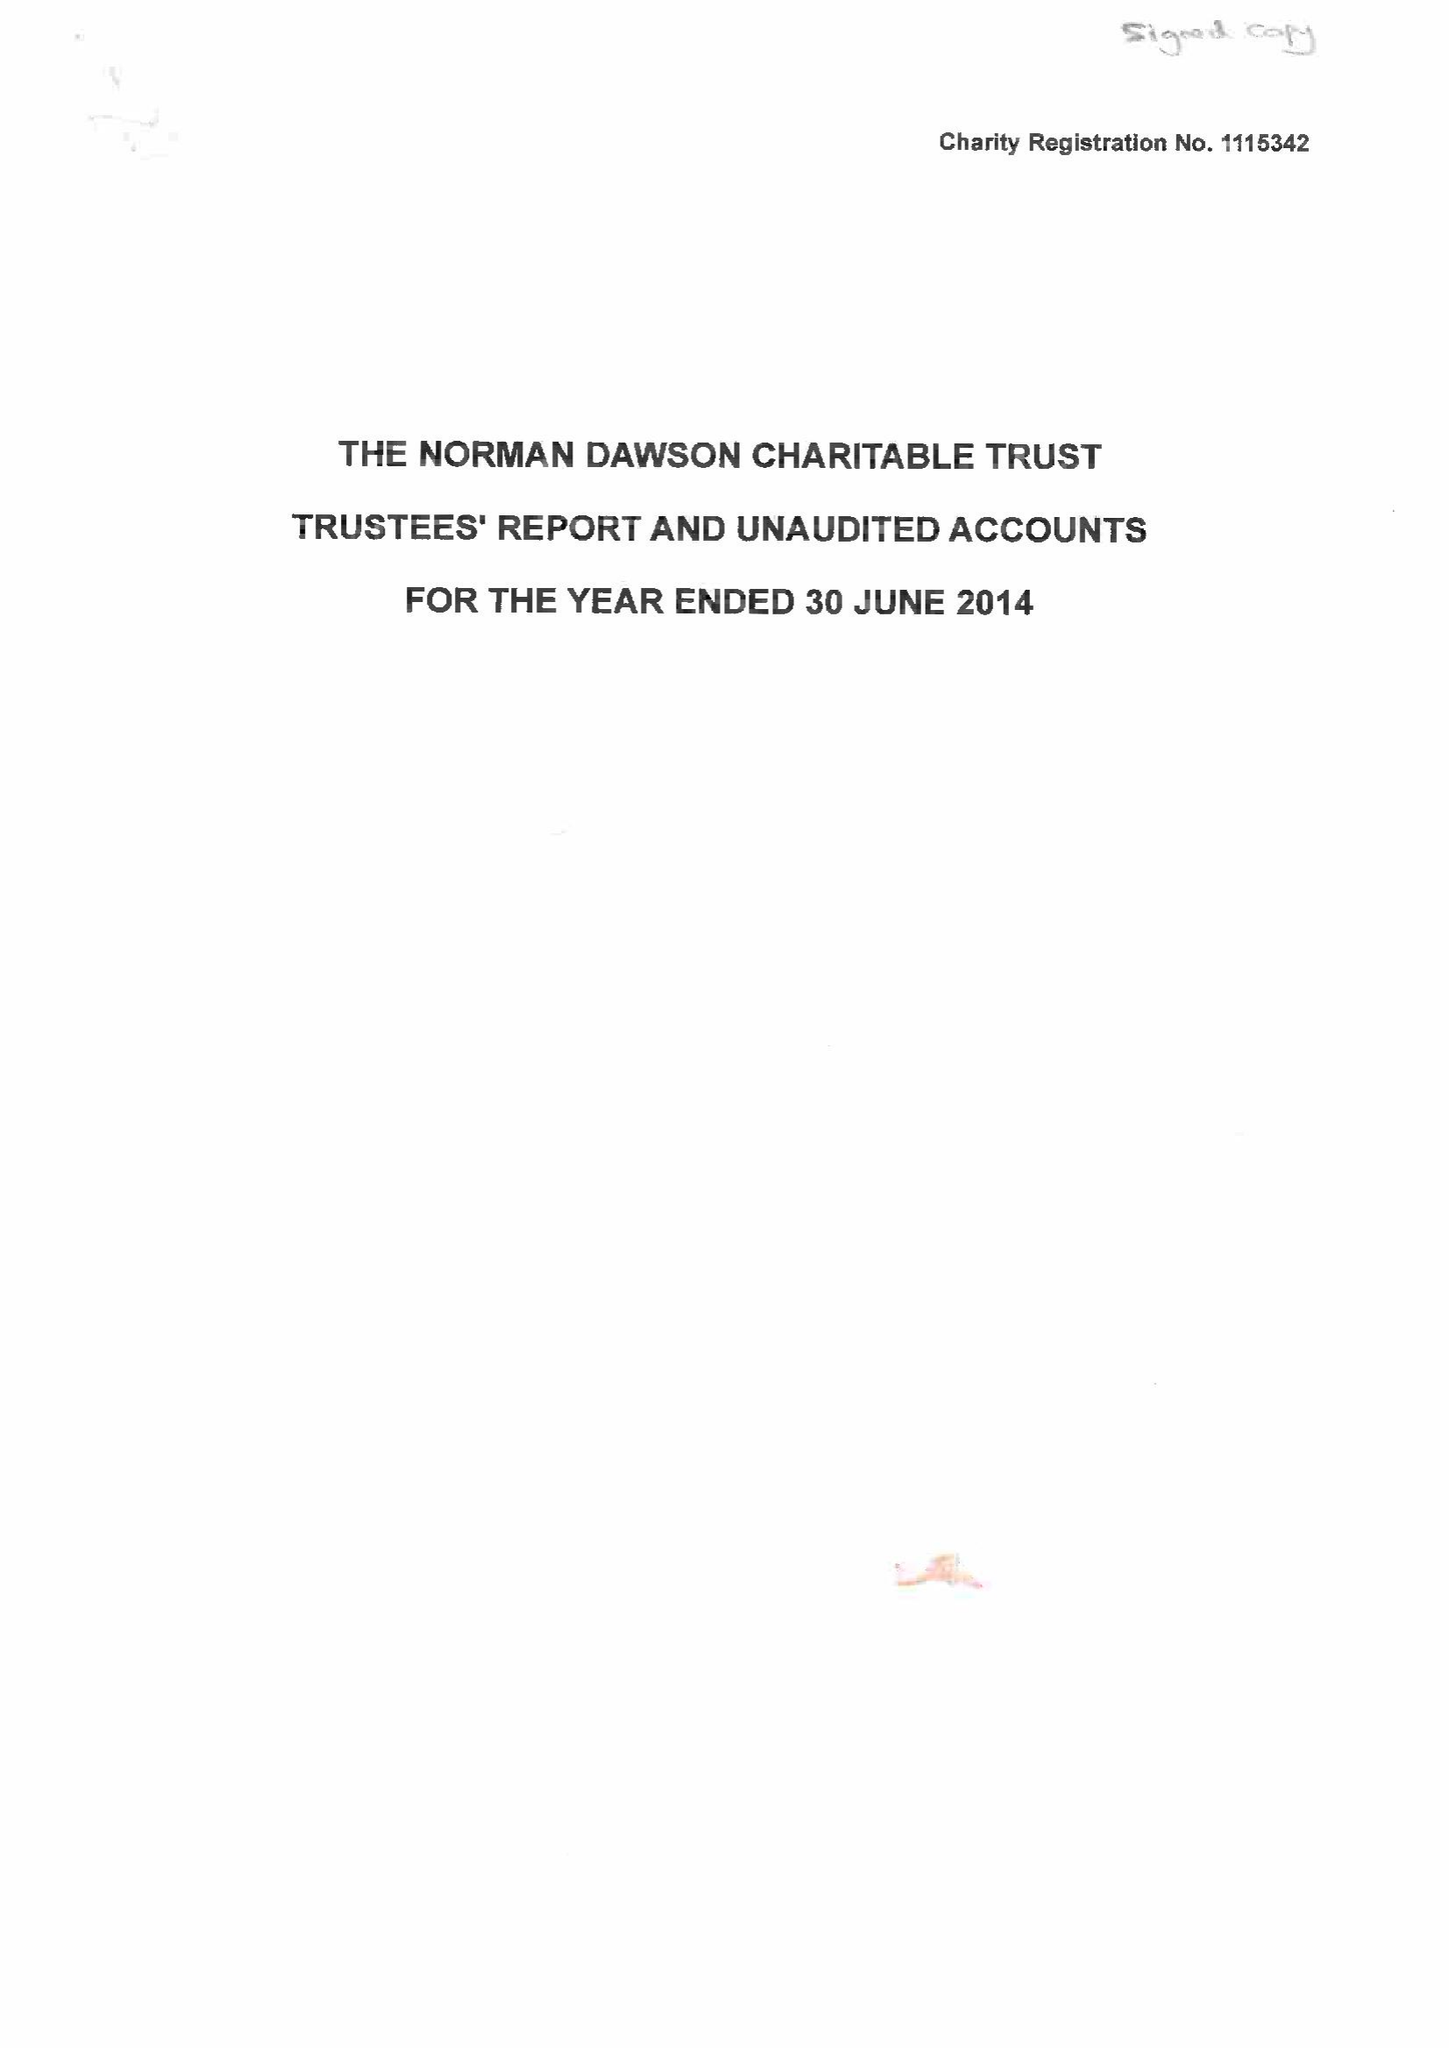What is the value for the address__post_town?
Answer the question using a single word or phrase. KIDDERMINSTER 